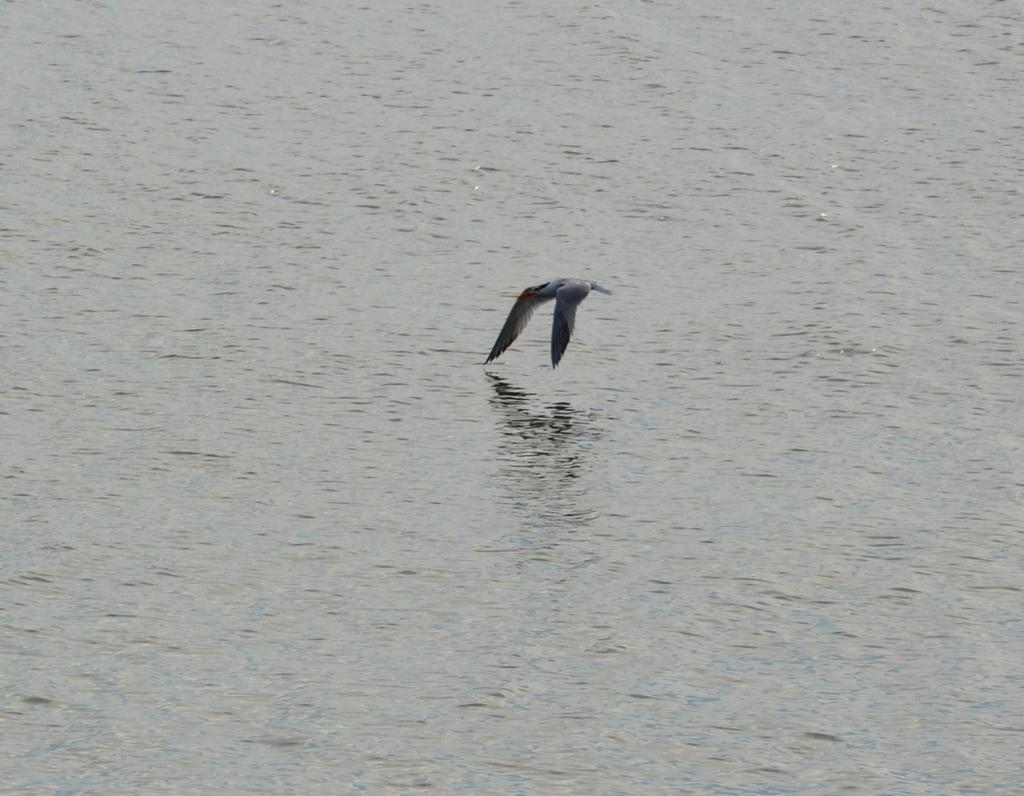What is the main subject of the image? The main subject of the image is a bird flying in the center of the image. Can you describe the bird's location in the image? The bird is flying in the center of the image. What can be seen in the background of the image? There is water visible in the background of the image. Is there a parcel being delivered by the bird in the image? No, there is no parcel being delivered by the bird in the image. Is the bird on vacation in the image? There is no indication in the image that the bird is on vacation. 